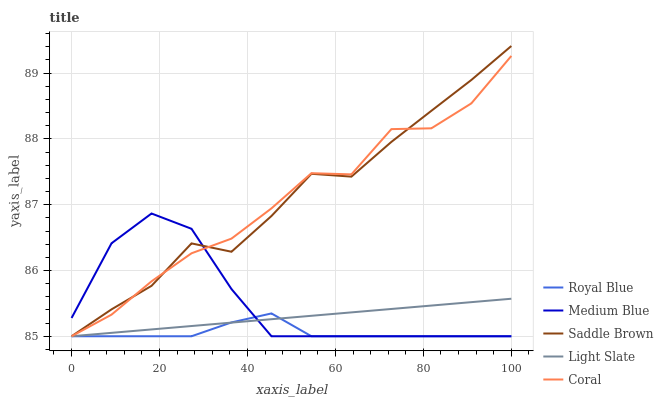Does Royal Blue have the minimum area under the curve?
Answer yes or no. Yes. Does Saddle Brown have the maximum area under the curve?
Answer yes or no. Yes. Does Coral have the minimum area under the curve?
Answer yes or no. No. Does Coral have the maximum area under the curve?
Answer yes or no. No. Is Light Slate the smoothest?
Answer yes or no. Yes. Is Coral the roughest?
Answer yes or no. Yes. Is Royal Blue the smoothest?
Answer yes or no. No. Is Royal Blue the roughest?
Answer yes or no. No. Does Light Slate have the lowest value?
Answer yes or no. Yes. Does Saddle Brown have the highest value?
Answer yes or no. Yes. Does Coral have the highest value?
Answer yes or no. No. Does Light Slate intersect Medium Blue?
Answer yes or no. Yes. Is Light Slate less than Medium Blue?
Answer yes or no. No. Is Light Slate greater than Medium Blue?
Answer yes or no. No. 